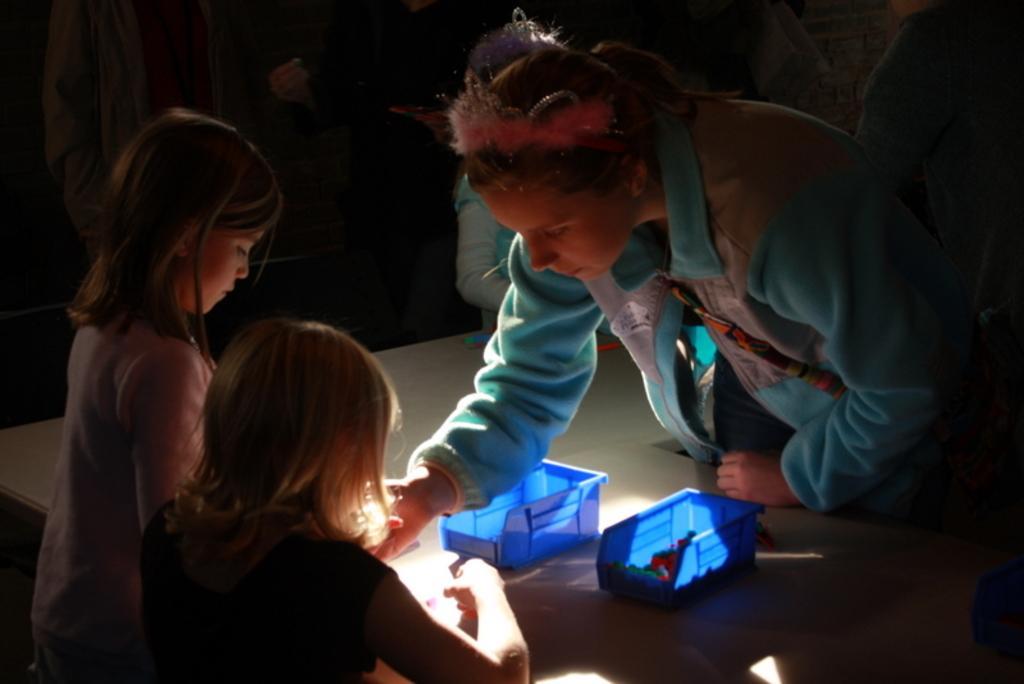Can you describe this image briefly? This is a picture of a woman and 2 girls who are playing with the toy and there is a basket of toys in the table. 